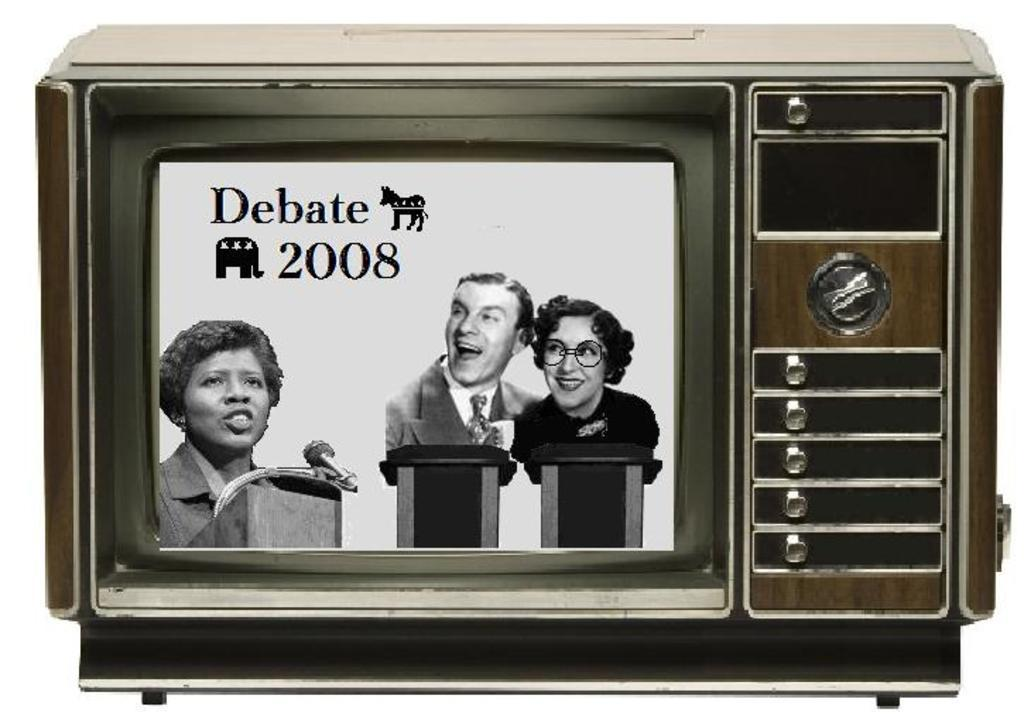<image>
Offer a succinct explanation of the picture presented. An old style TV screen shows a satirical image about a 2008 debate. 